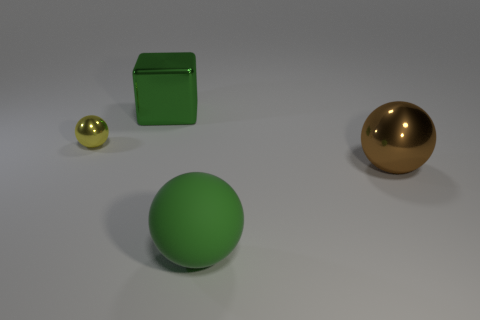Is there anything else that has the same size as the yellow metal object?
Offer a terse response. No. Is the big thing that is behind the small yellow thing made of the same material as the green sphere?
Offer a terse response. No. What shape is the large brown thing?
Provide a short and direct response. Sphere. How many green objects are either big metal blocks or rubber balls?
Your answer should be very brief. 2. What number of other things are there of the same material as the small ball
Your answer should be very brief. 2. There is a object that is on the right side of the big rubber thing; is it the same shape as the tiny yellow object?
Your answer should be compact. Yes. Are any red rubber cubes visible?
Provide a short and direct response. No. Is there anything else that is the same shape as the big green metal object?
Give a very brief answer. No. Are there more objects that are on the left side of the big rubber sphere than small shiny objects?
Your response must be concise. Yes. There is a big brown metal sphere; are there any small objects on the right side of it?
Provide a short and direct response. No. 